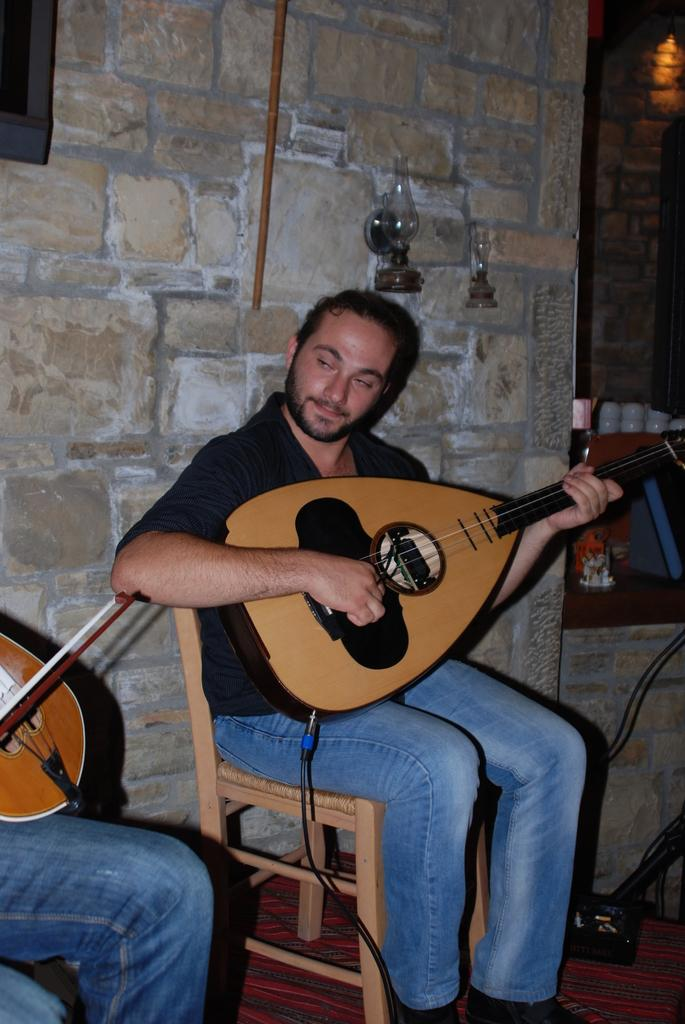What is the person in the image wearing? The person is wearing a black shirt in the image. What is the person doing while wearing the black shirt? The person is sitting and playing a guitar. Are there any other people in the image? Yes, there is another person in the image. What is the second person playing? The second person is playing a violin. How does the person use their nose to play the guitar in the image? The person does not use their nose to play the guitar in the image; they are using their hands to play the instrument. 